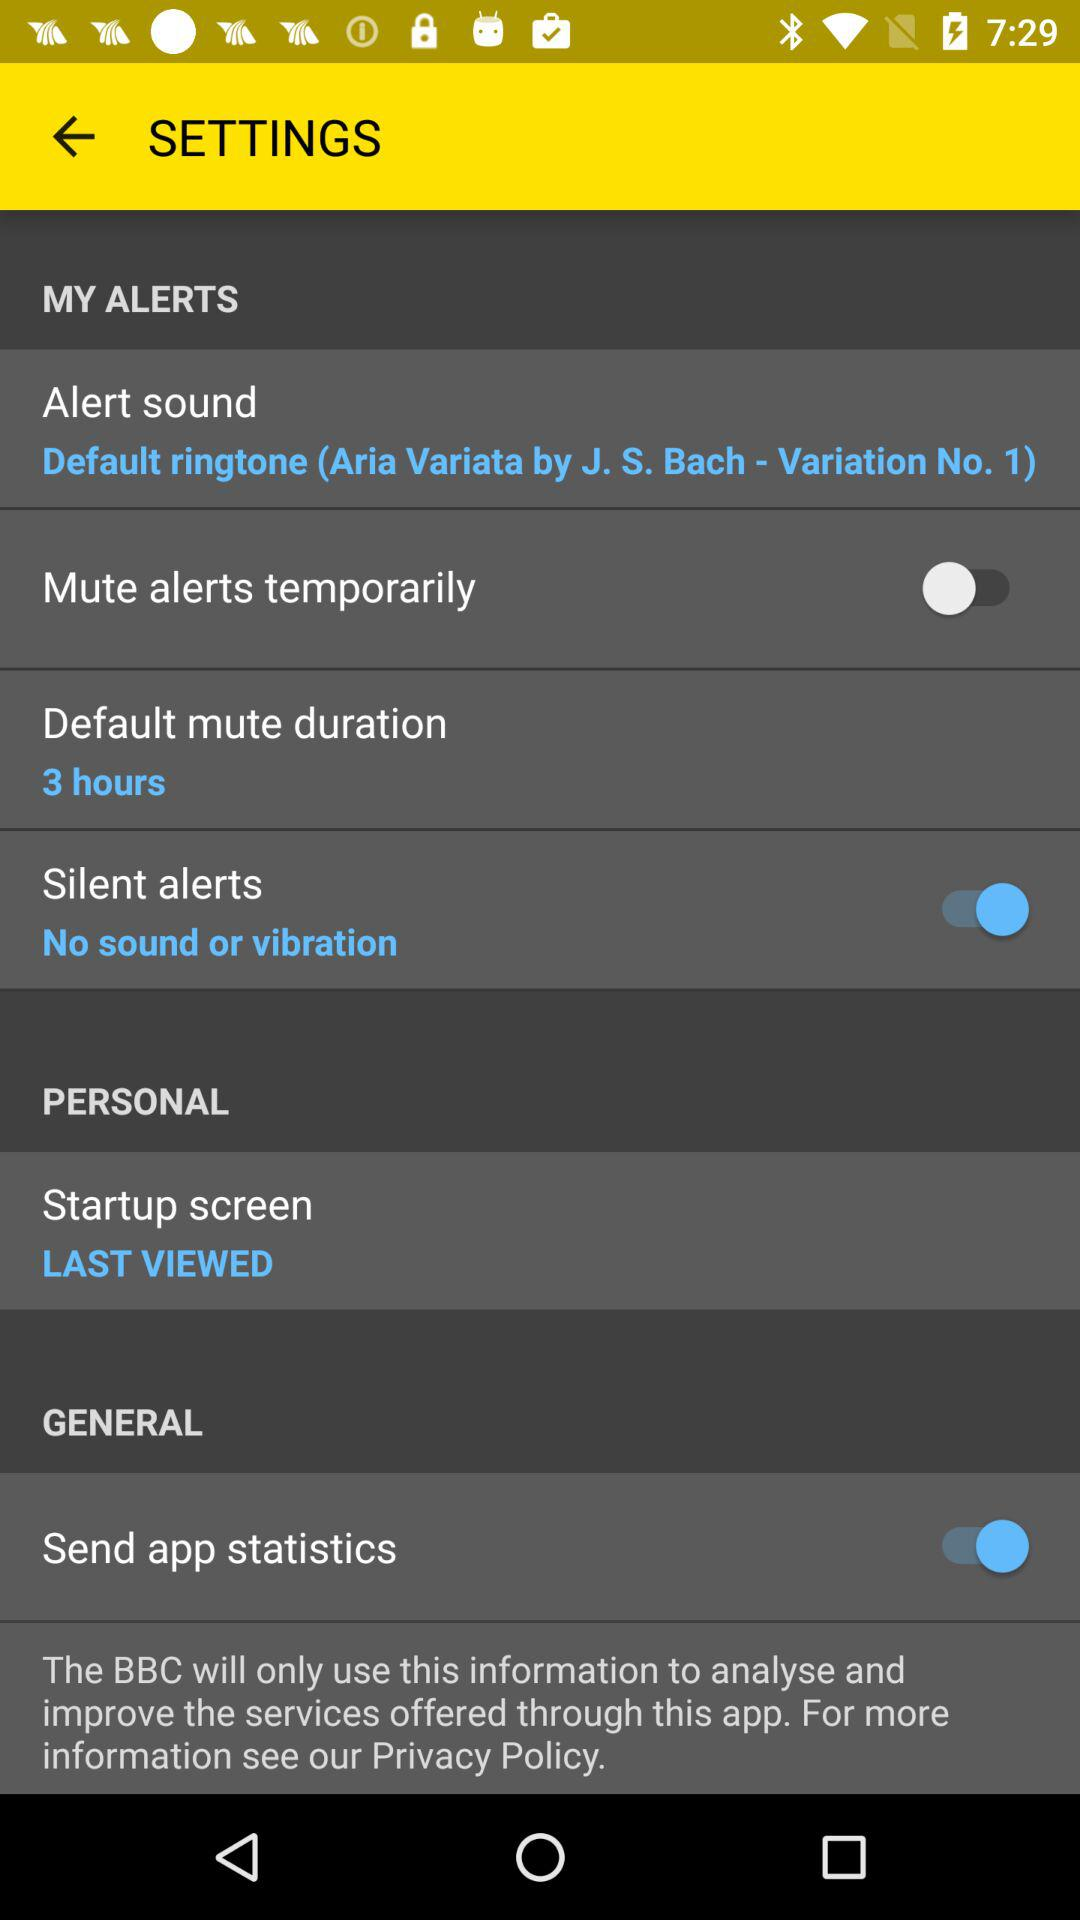What is the status of "Send app statistics"? The status of "Send app statistics" is "on". 